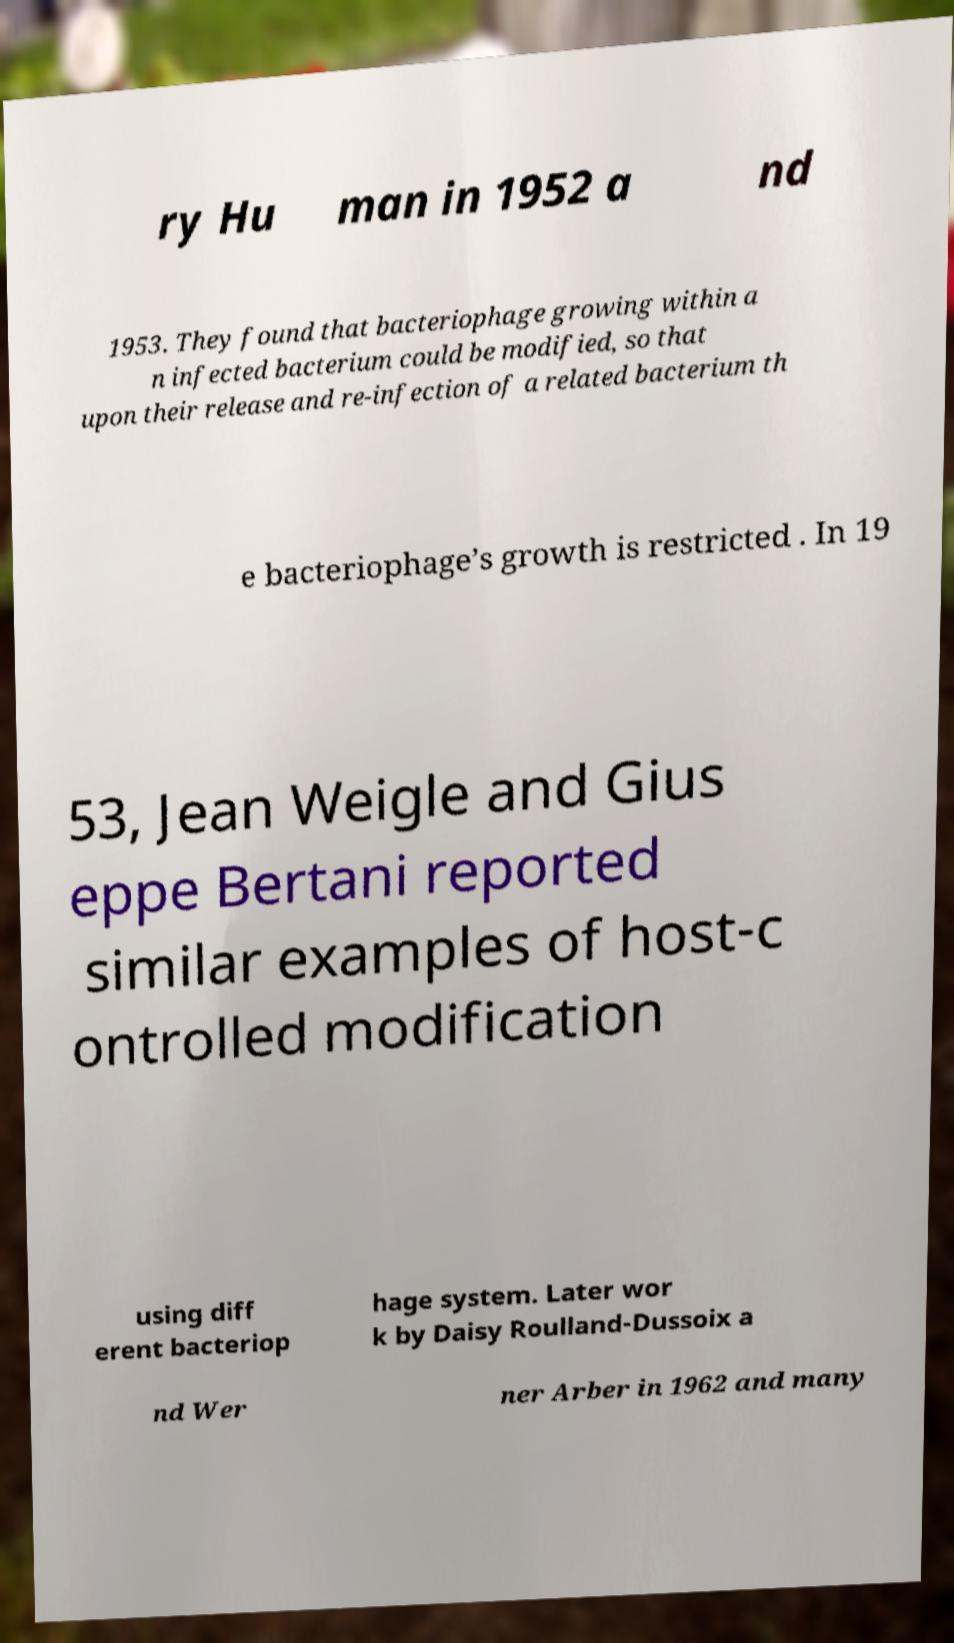I need the written content from this picture converted into text. Can you do that? ry Hu man in 1952 a nd 1953. They found that bacteriophage growing within a n infected bacterium could be modified, so that upon their release and re-infection of a related bacterium th e bacteriophage’s growth is restricted . In 19 53, Jean Weigle and Gius eppe Bertani reported similar examples of host-c ontrolled modification using diff erent bacteriop hage system. Later wor k by Daisy Roulland-Dussoix a nd Wer ner Arber in 1962 and many 